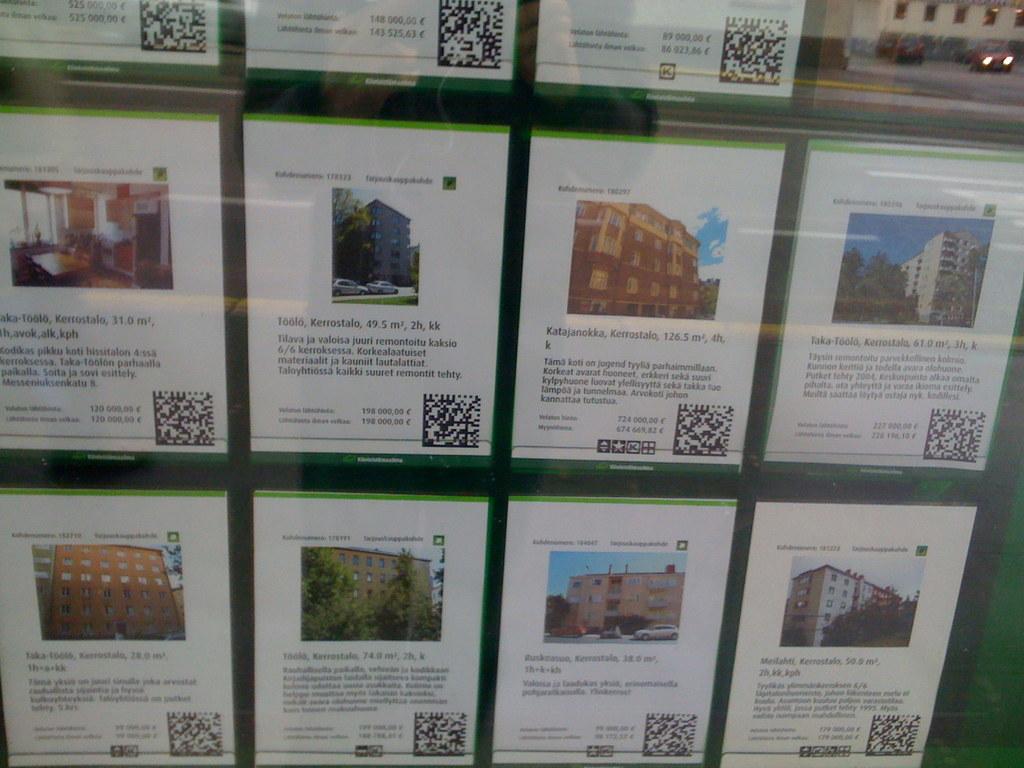How many square meters is the middle one, second from the left?
Keep it short and to the point. 49.5. 